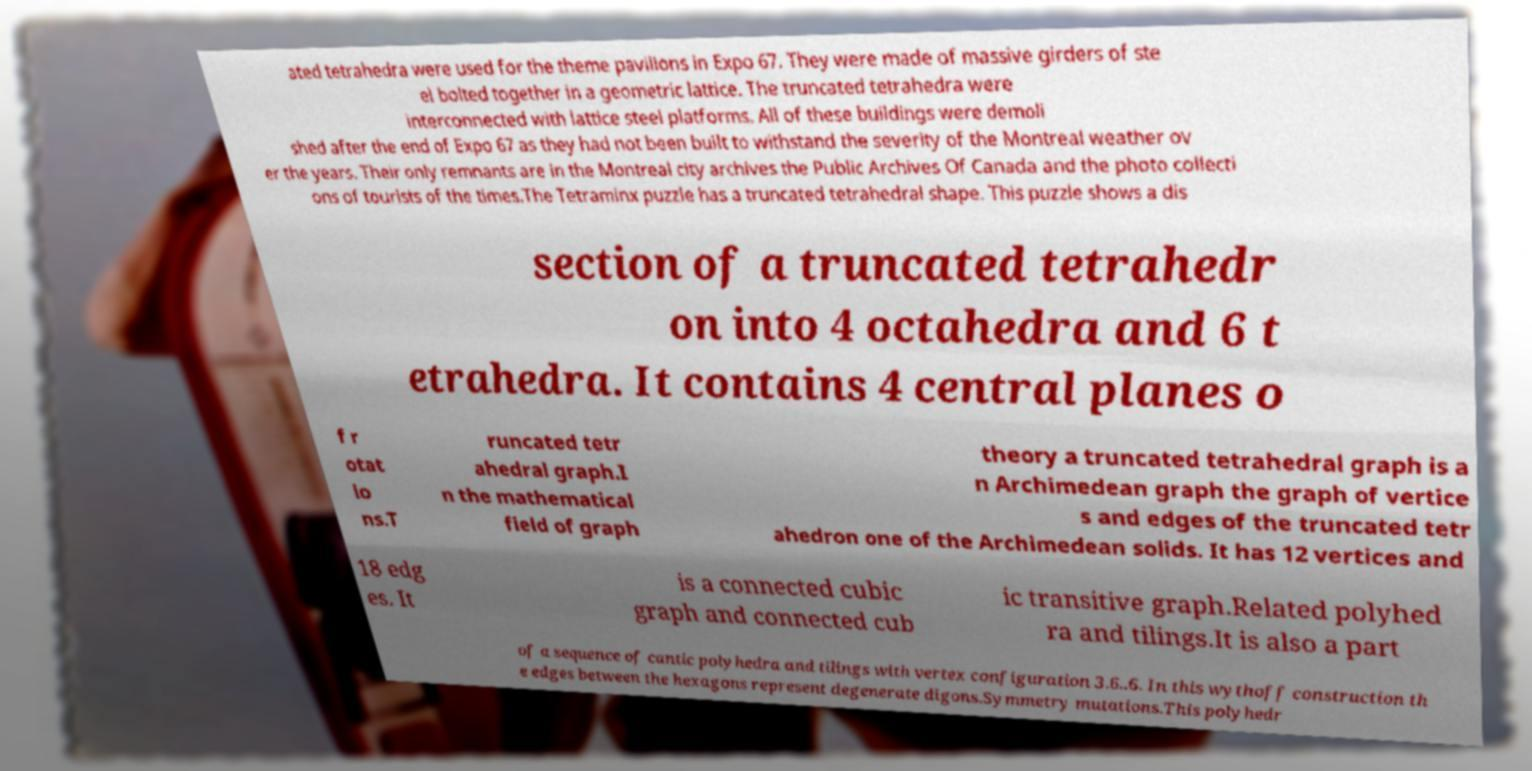Could you extract and type out the text from this image? ated tetrahedra were used for the theme pavilions in Expo 67. They were made of massive girders of ste el bolted together in a geometric lattice. The truncated tetrahedra were interconnected with lattice steel platforms. All of these buildings were demoli shed after the end of Expo 67 as they had not been built to withstand the severity of the Montreal weather ov er the years. Their only remnants are in the Montreal city archives the Public Archives Of Canada and the photo collecti ons of tourists of the times.The Tetraminx puzzle has a truncated tetrahedral shape. This puzzle shows a dis section of a truncated tetrahedr on into 4 octahedra and 6 t etrahedra. It contains 4 central planes o f r otat io ns.T runcated tetr ahedral graph.I n the mathematical field of graph theory a truncated tetrahedral graph is a n Archimedean graph the graph of vertice s and edges of the truncated tetr ahedron one of the Archimedean solids. It has 12 vertices and 18 edg es. It is a connected cubic graph and connected cub ic transitive graph.Related polyhed ra and tilings.It is also a part of a sequence of cantic polyhedra and tilings with vertex configuration 3.6..6. In this wythoff construction th e edges between the hexagons represent degenerate digons.Symmetry mutations.This polyhedr 